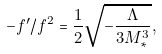Convert formula to latex. <formula><loc_0><loc_0><loc_500><loc_500>- f ^ { \prime } / f ^ { 2 } = \frac { 1 } { 2 } \sqrt { - \frac { \Lambda } { 3 M _ { * } ^ { 3 } } } ,</formula> 